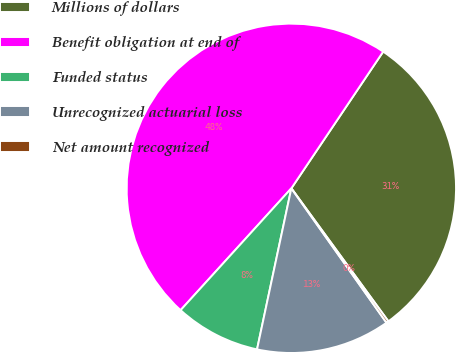<chart> <loc_0><loc_0><loc_500><loc_500><pie_chart><fcel>Millions of dollars<fcel>Benefit obligation at end of<fcel>Funded status<fcel>Unrecognized actuarial loss<fcel>Net amount recognized<nl><fcel>30.55%<fcel>47.67%<fcel>8.4%<fcel>13.14%<fcel>0.23%<nl></chart> 